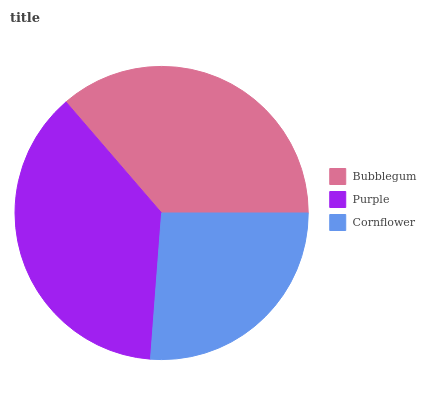Is Cornflower the minimum?
Answer yes or no. Yes. Is Purple the maximum?
Answer yes or no. Yes. Is Purple the minimum?
Answer yes or no. No. Is Cornflower the maximum?
Answer yes or no. No. Is Purple greater than Cornflower?
Answer yes or no. Yes. Is Cornflower less than Purple?
Answer yes or no. Yes. Is Cornflower greater than Purple?
Answer yes or no. No. Is Purple less than Cornflower?
Answer yes or no. No. Is Bubblegum the high median?
Answer yes or no. Yes. Is Bubblegum the low median?
Answer yes or no. Yes. Is Cornflower the high median?
Answer yes or no. No. Is Cornflower the low median?
Answer yes or no. No. 